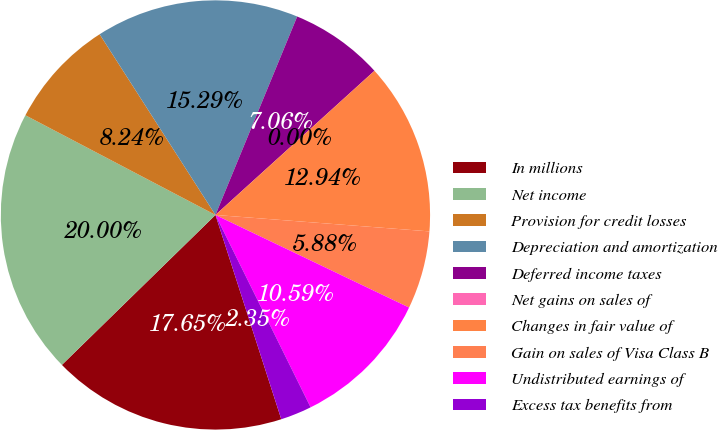<chart> <loc_0><loc_0><loc_500><loc_500><pie_chart><fcel>In millions<fcel>Net income<fcel>Provision for credit losses<fcel>Depreciation and amortization<fcel>Deferred income taxes<fcel>Net gains on sales of<fcel>Changes in fair value of<fcel>Gain on sales of Visa Class B<fcel>Undistributed earnings of<fcel>Excess tax benefits from<nl><fcel>17.65%<fcel>20.0%<fcel>8.24%<fcel>15.29%<fcel>7.06%<fcel>0.0%<fcel>12.94%<fcel>5.88%<fcel>10.59%<fcel>2.35%<nl></chart> 